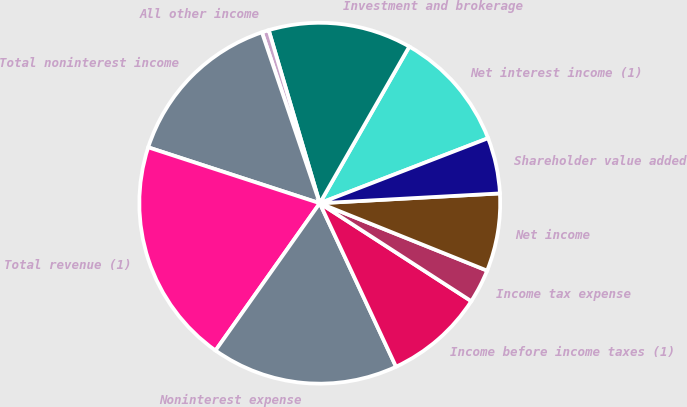<chart> <loc_0><loc_0><loc_500><loc_500><pie_chart><fcel>Net interest income (1)<fcel>Investment and brokerage<fcel>All other income<fcel>Total noninterest income<fcel>Total revenue (1)<fcel>Noninterest expense<fcel>Income before income taxes (1)<fcel>Income tax expense<fcel>Net income<fcel>Shareholder value added<nl><fcel>10.87%<fcel>12.83%<fcel>0.63%<fcel>14.79%<fcel>20.21%<fcel>16.75%<fcel>8.92%<fcel>3.04%<fcel>6.96%<fcel>5.0%<nl></chart> 